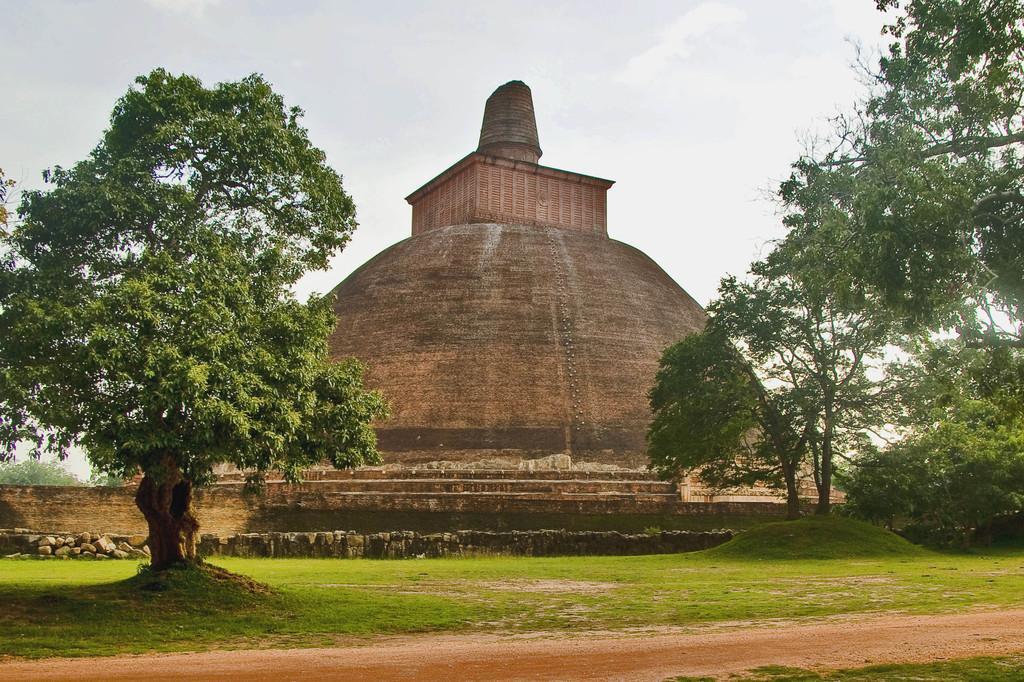Could you give a brief overview of what you see in this image? In the picture we can see the grassland, trees on either side of the image, we can see the stone wall, stone architecture building and the plain sky in the background. 